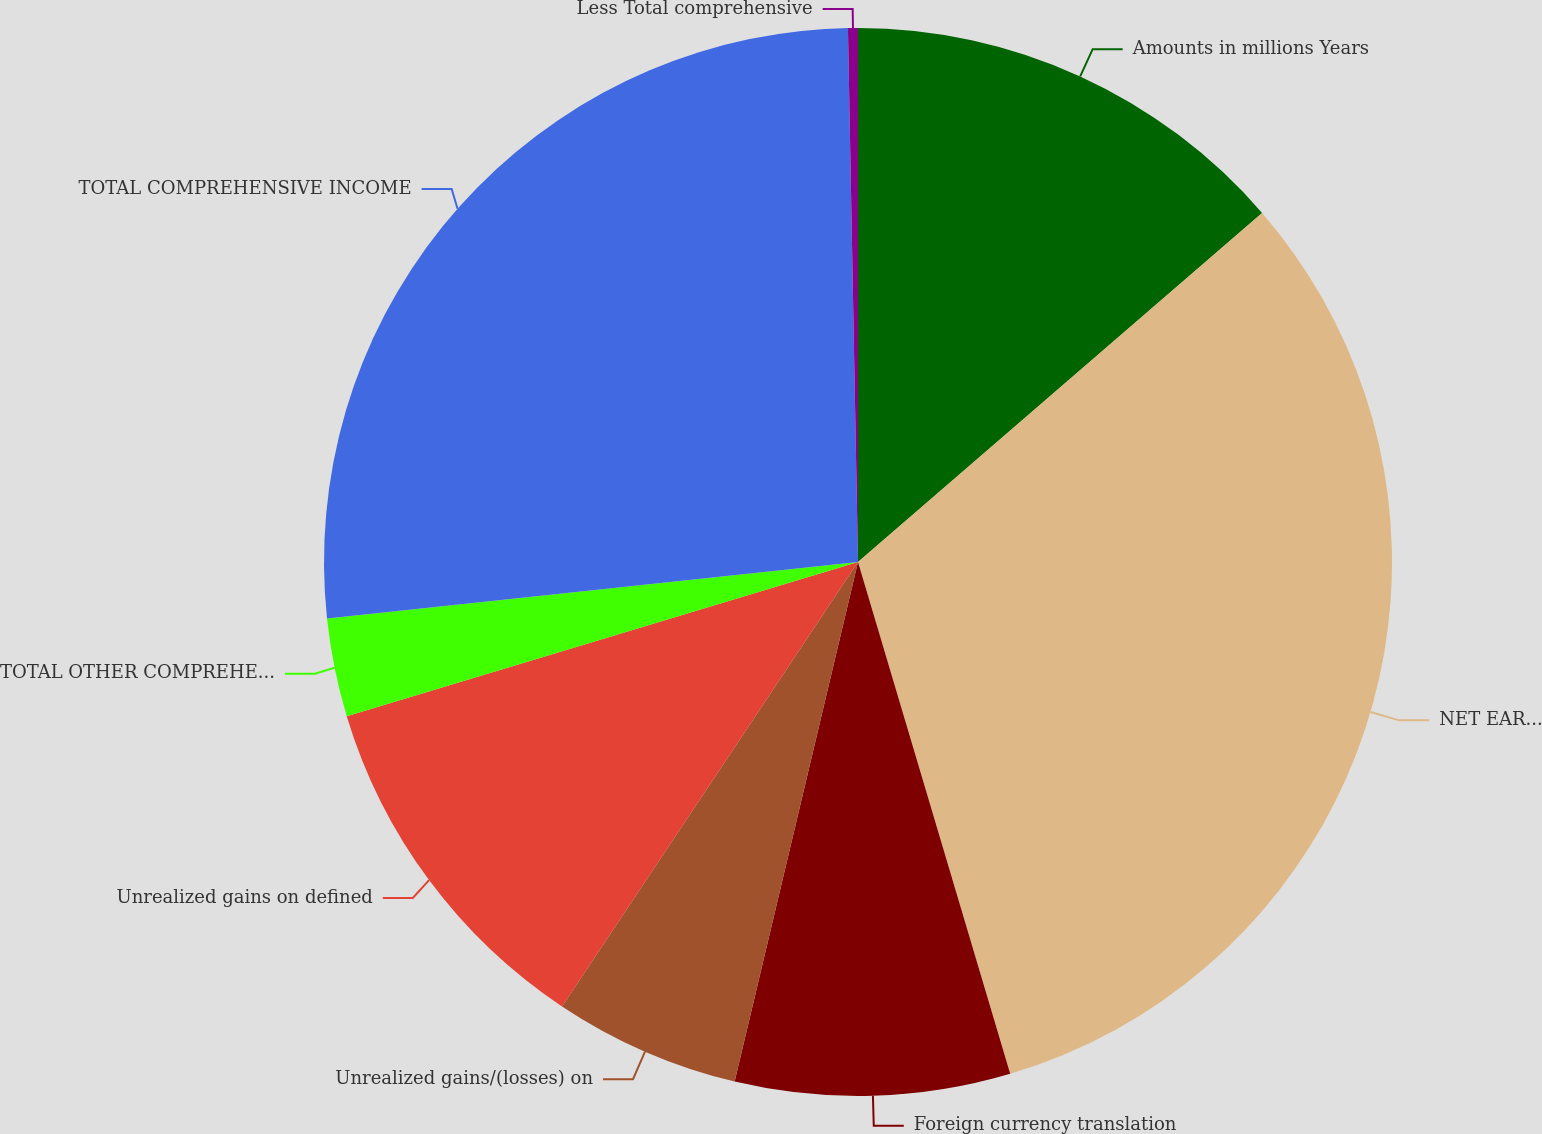Convert chart to OTSL. <chart><loc_0><loc_0><loc_500><loc_500><pie_chart><fcel>Amounts in millions Years<fcel>NET EARNINGS<fcel>Foreign currency translation<fcel>Unrealized gains/(losses) on<fcel>Unrealized gains on defined<fcel>TOTAL OTHER COMPREHENSIVE<fcel>TOTAL COMPREHENSIVE INCOME<fcel>Less Total comprehensive<nl><fcel>13.66%<fcel>31.74%<fcel>8.31%<fcel>5.64%<fcel>10.99%<fcel>2.97%<fcel>26.39%<fcel>0.3%<nl></chart> 